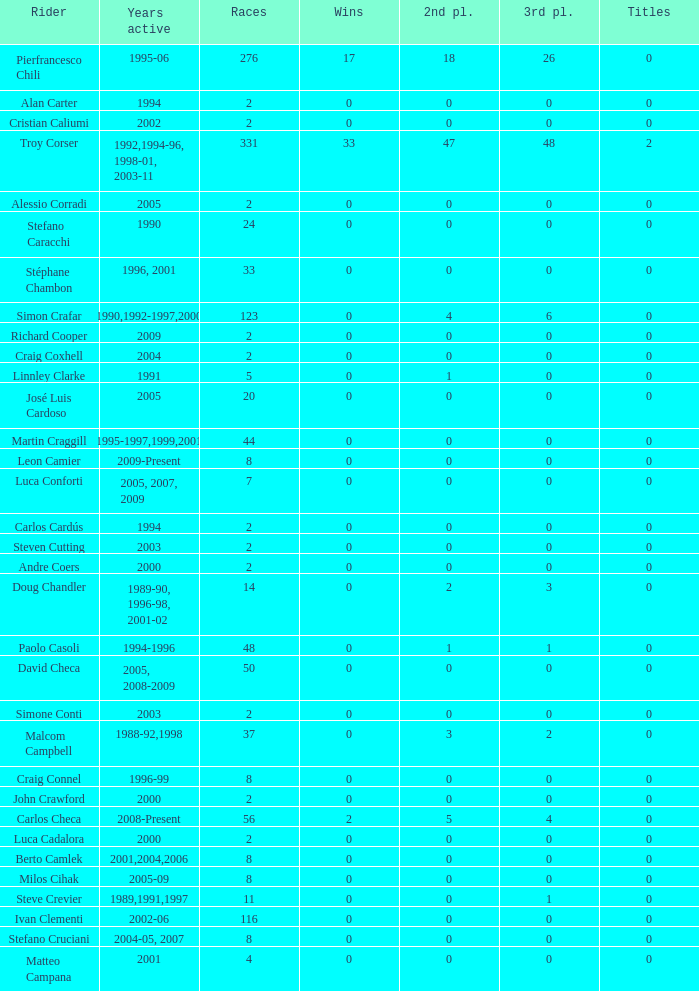What is the total number of wins for riders with fewer than 56 races and more than 0 titles? 0.0. 